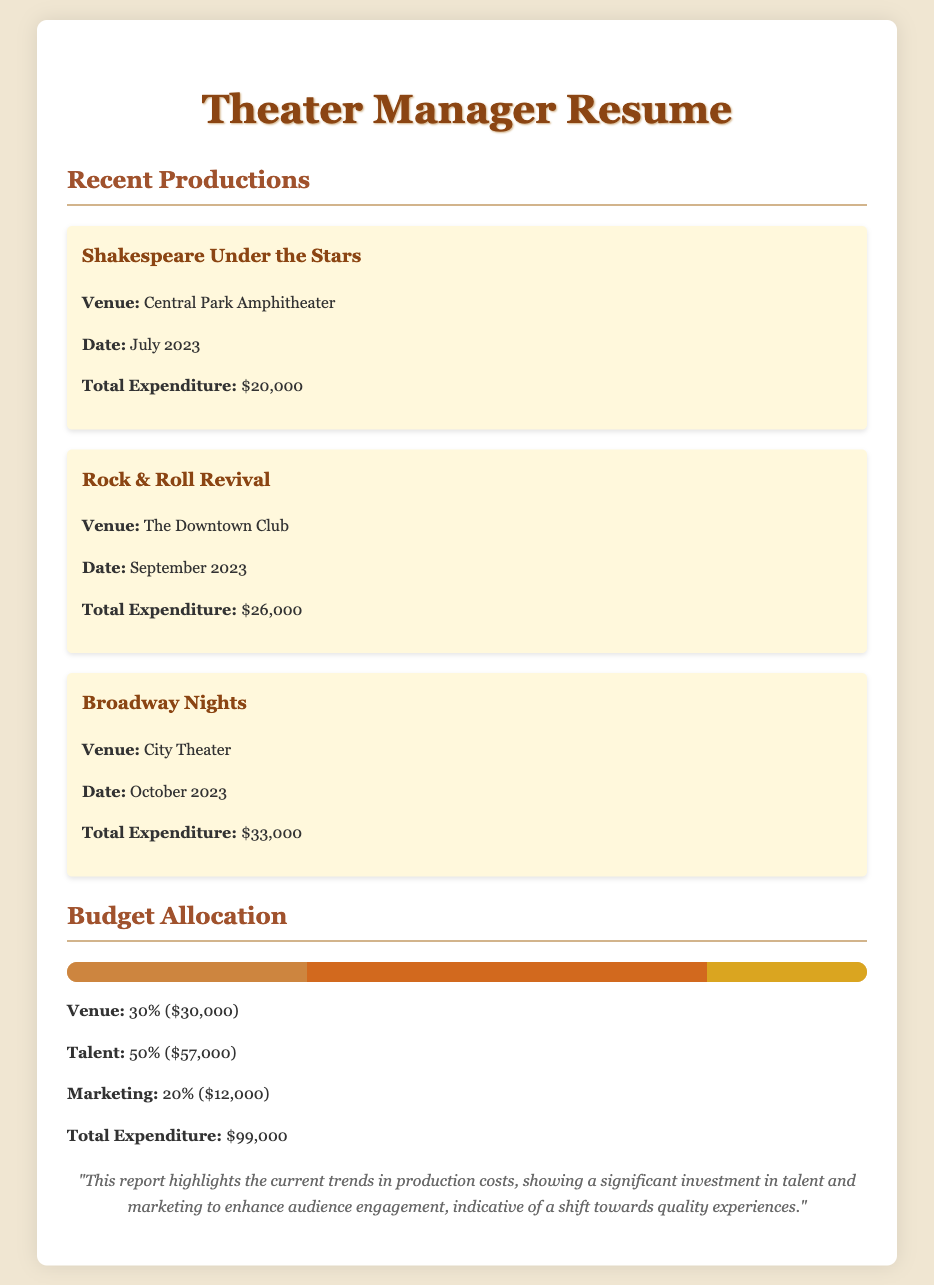What is the venue for "Shakespeare Under the Stars"? The venue listed for "Shakespeare Under the Stars" is Central Park Amphitheater.
Answer: Central Park Amphitheater What is the total expenditure for "Rock & Roll Revival"? The total expenditure specified for "Rock & Roll Revival" is $26,000.
Answer: $26,000 What percentage of the budget is allocated to marketing? The document indicates that marketing receives 20% of the total budget allocation.
Answer: 20% Which production has the highest total expenditure? The production with the highest total expenditure is "Broadway Nights," totaling $33,000.
Answer: Broadway Nights What was the date of the production "Broadway Nights"? The production "Broadway Nights" took place in October 2023.
Answer: October 2023 How much was spent on talent across all productions? The document shows that the total expenditure on talent is $57,000, representing 50% of the budget allocation.
Answer: $57,000 What is the total expenditure for all productions combined? The total expenditure for all productions, as stated, is $99,000.
Answer: $99,000 What is the total budget allocated for venues? The document states that the budget allocated for venues is $30,000, which is 30% of the total.
Answer: $30,000 What type of document is this? This document is a resume, specifically for a theater manager detailing cost analysis and budget allocations.
Answer: Resume 